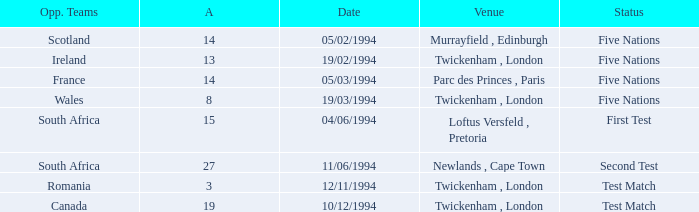How many against have a status of first test? 1.0. 